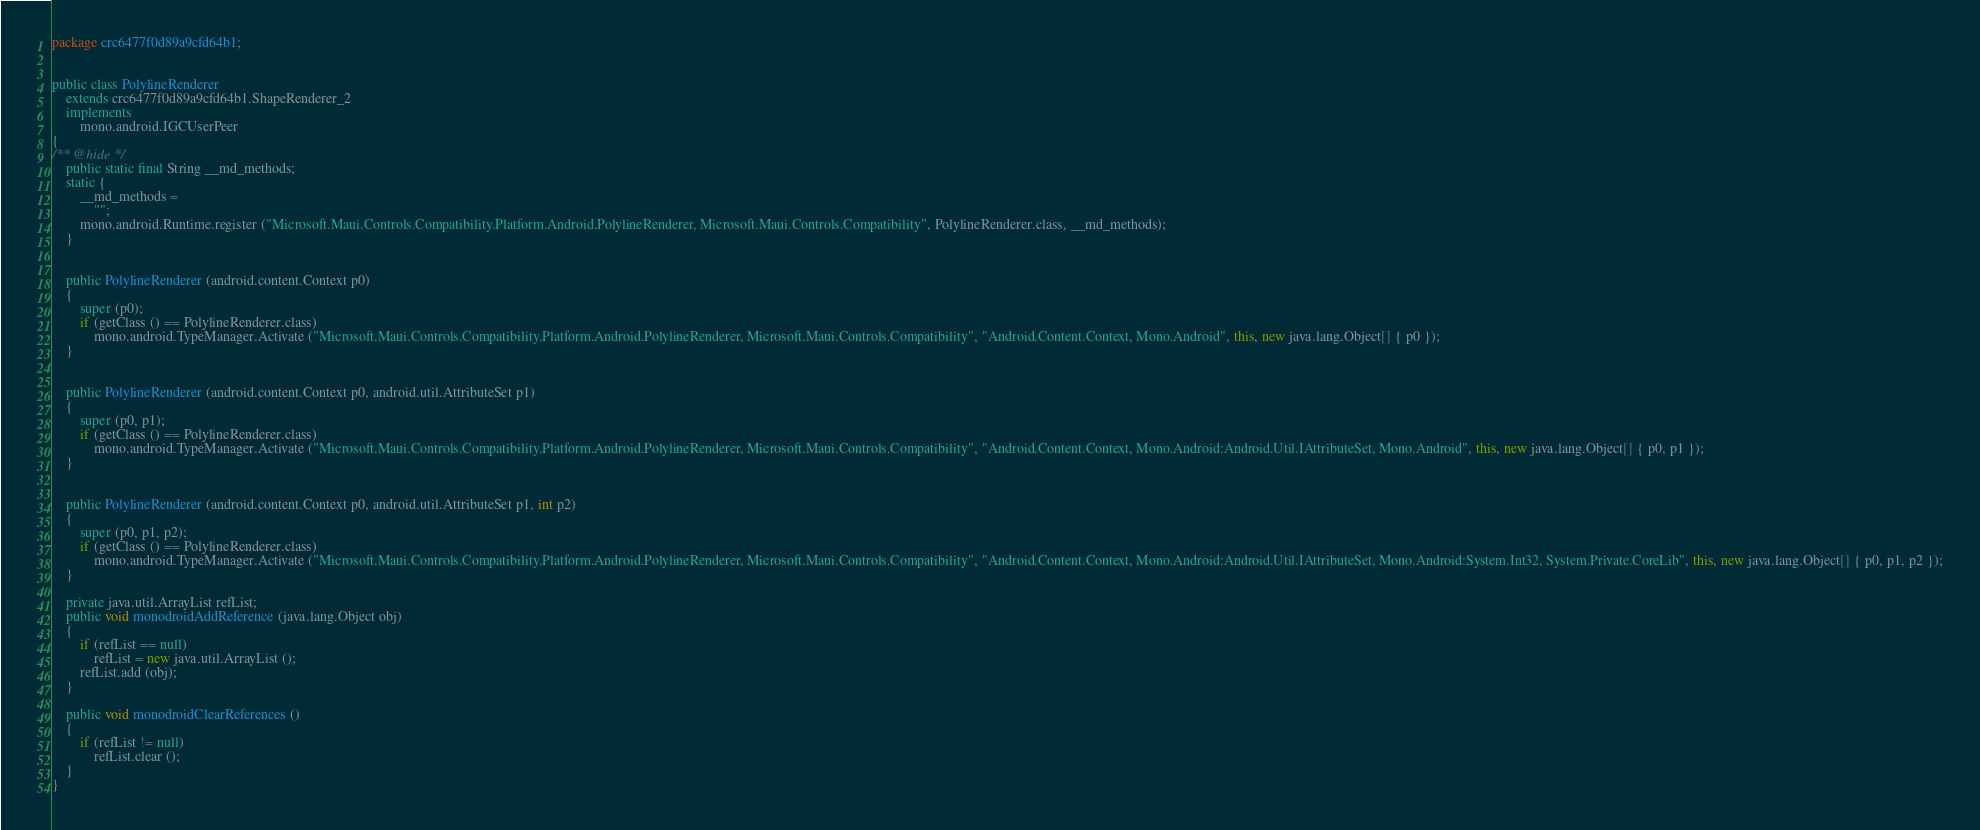<code> <loc_0><loc_0><loc_500><loc_500><_Java_>package crc6477f0d89a9cfd64b1;


public class PolylineRenderer
	extends crc6477f0d89a9cfd64b1.ShapeRenderer_2
	implements
		mono.android.IGCUserPeer
{
/** @hide */
	public static final String __md_methods;
	static {
		__md_methods = 
			"";
		mono.android.Runtime.register ("Microsoft.Maui.Controls.Compatibility.Platform.Android.PolylineRenderer, Microsoft.Maui.Controls.Compatibility", PolylineRenderer.class, __md_methods);
	}


	public PolylineRenderer (android.content.Context p0)
	{
		super (p0);
		if (getClass () == PolylineRenderer.class)
			mono.android.TypeManager.Activate ("Microsoft.Maui.Controls.Compatibility.Platform.Android.PolylineRenderer, Microsoft.Maui.Controls.Compatibility", "Android.Content.Context, Mono.Android", this, new java.lang.Object[] { p0 });
	}


	public PolylineRenderer (android.content.Context p0, android.util.AttributeSet p1)
	{
		super (p0, p1);
		if (getClass () == PolylineRenderer.class)
			mono.android.TypeManager.Activate ("Microsoft.Maui.Controls.Compatibility.Platform.Android.PolylineRenderer, Microsoft.Maui.Controls.Compatibility", "Android.Content.Context, Mono.Android:Android.Util.IAttributeSet, Mono.Android", this, new java.lang.Object[] { p0, p1 });
	}


	public PolylineRenderer (android.content.Context p0, android.util.AttributeSet p1, int p2)
	{
		super (p0, p1, p2);
		if (getClass () == PolylineRenderer.class)
			mono.android.TypeManager.Activate ("Microsoft.Maui.Controls.Compatibility.Platform.Android.PolylineRenderer, Microsoft.Maui.Controls.Compatibility", "Android.Content.Context, Mono.Android:Android.Util.IAttributeSet, Mono.Android:System.Int32, System.Private.CoreLib", this, new java.lang.Object[] { p0, p1, p2 });
	}

	private java.util.ArrayList refList;
	public void monodroidAddReference (java.lang.Object obj)
	{
		if (refList == null)
			refList = new java.util.ArrayList ();
		refList.add (obj);
	}

	public void monodroidClearReferences ()
	{
		if (refList != null)
			refList.clear ();
	}
}
</code> 